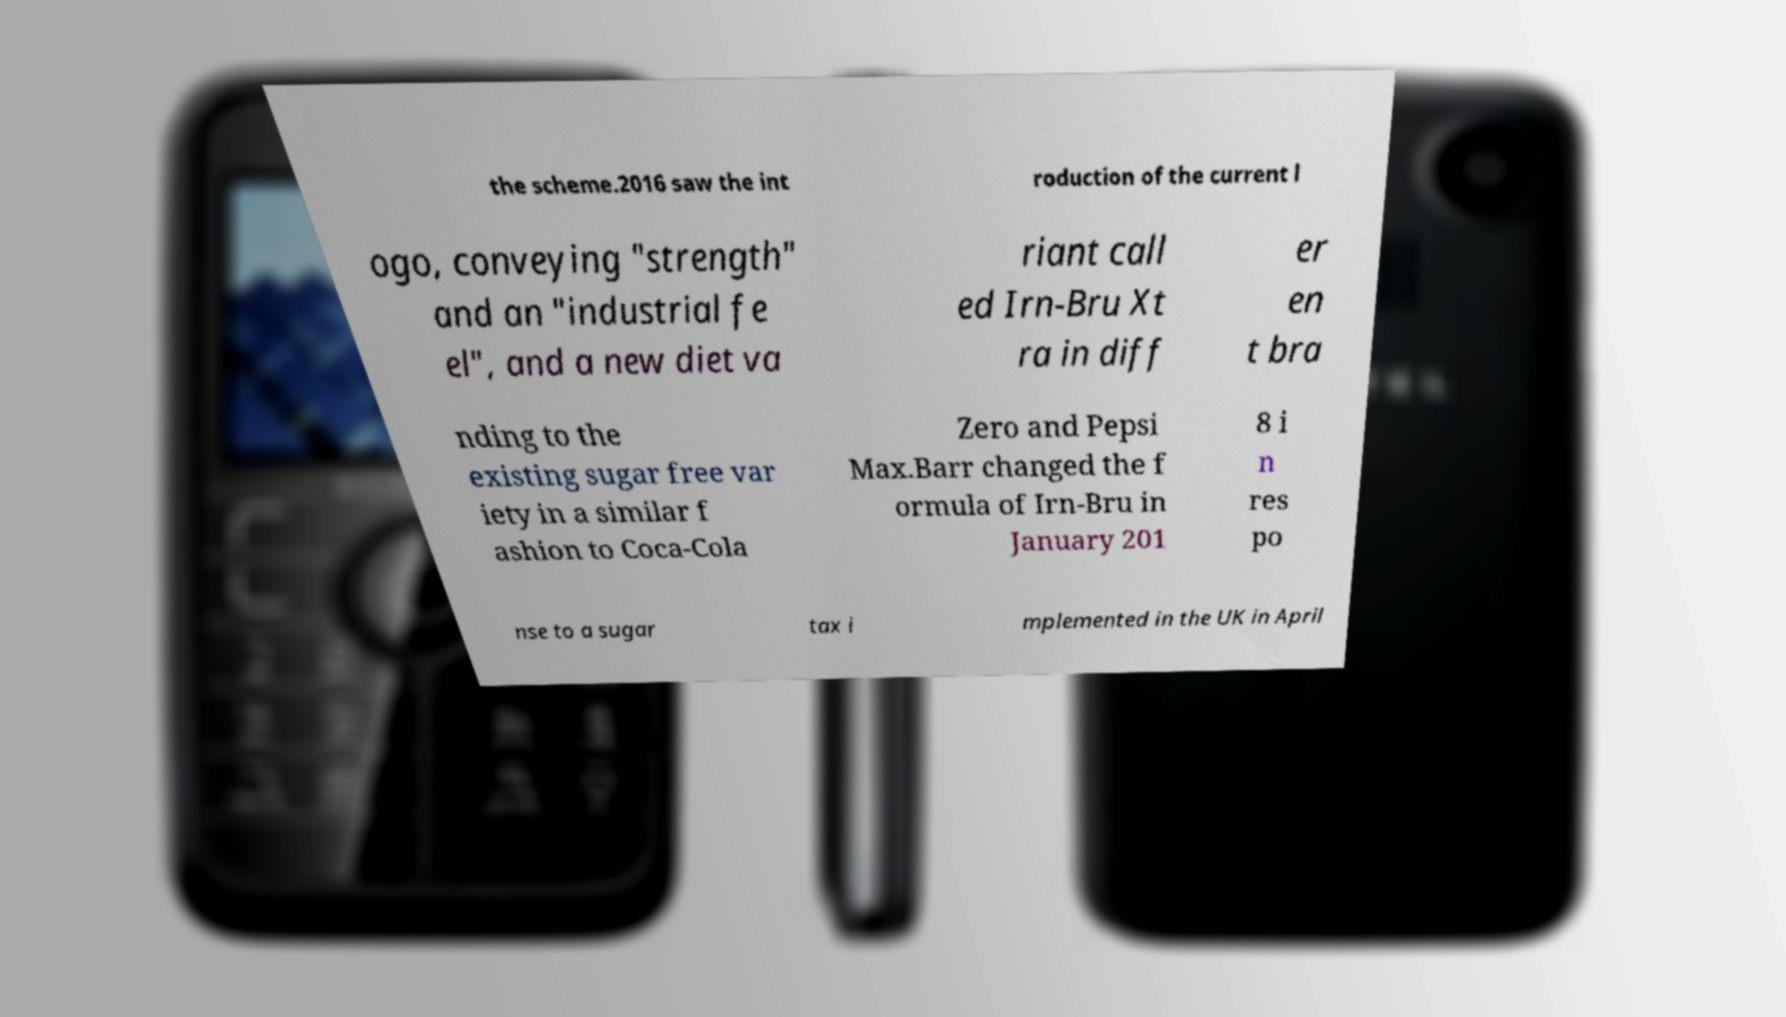I need the written content from this picture converted into text. Can you do that? the scheme.2016 saw the int roduction of the current l ogo, conveying "strength" and an "industrial fe el", and a new diet va riant call ed Irn-Bru Xt ra in diff er en t bra nding to the existing sugar free var iety in a similar f ashion to Coca-Cola Zero and Pepsi Max.Barr changed the f ormula of Irn-Bru in January 201 8 i n res po nse to a sugar tax i mplemented in the UK in April 